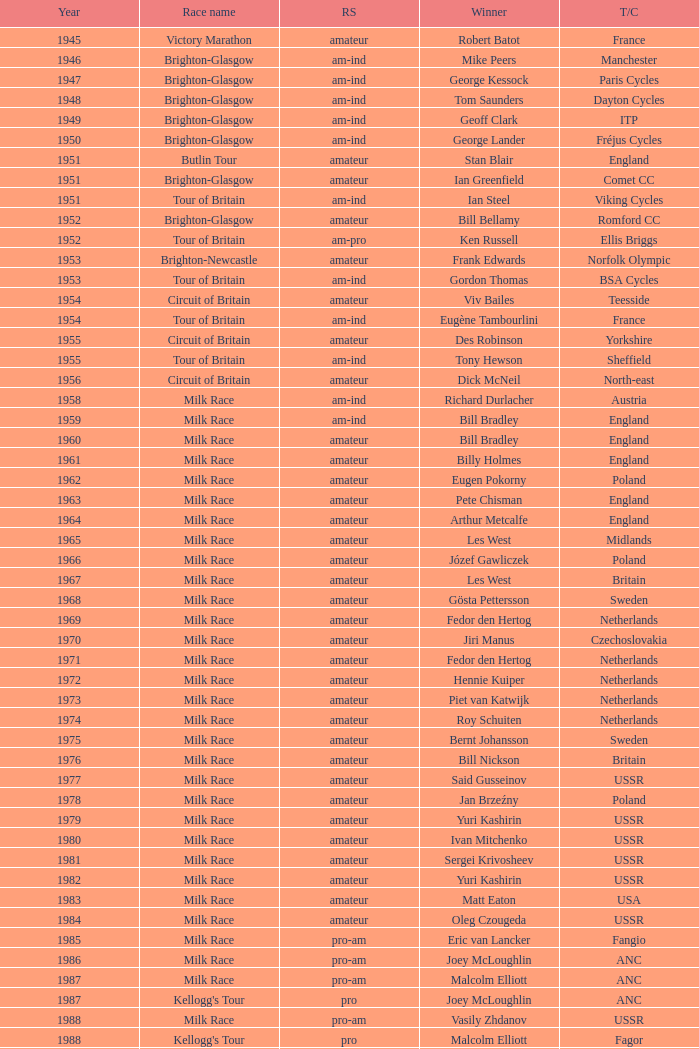What ream played later than 1958 in the kellogg's tour? ANC, Fagor, Z-Peugeot, Weinnmann-SMM, Motorola, Motorola, Motorola, Lampre. 